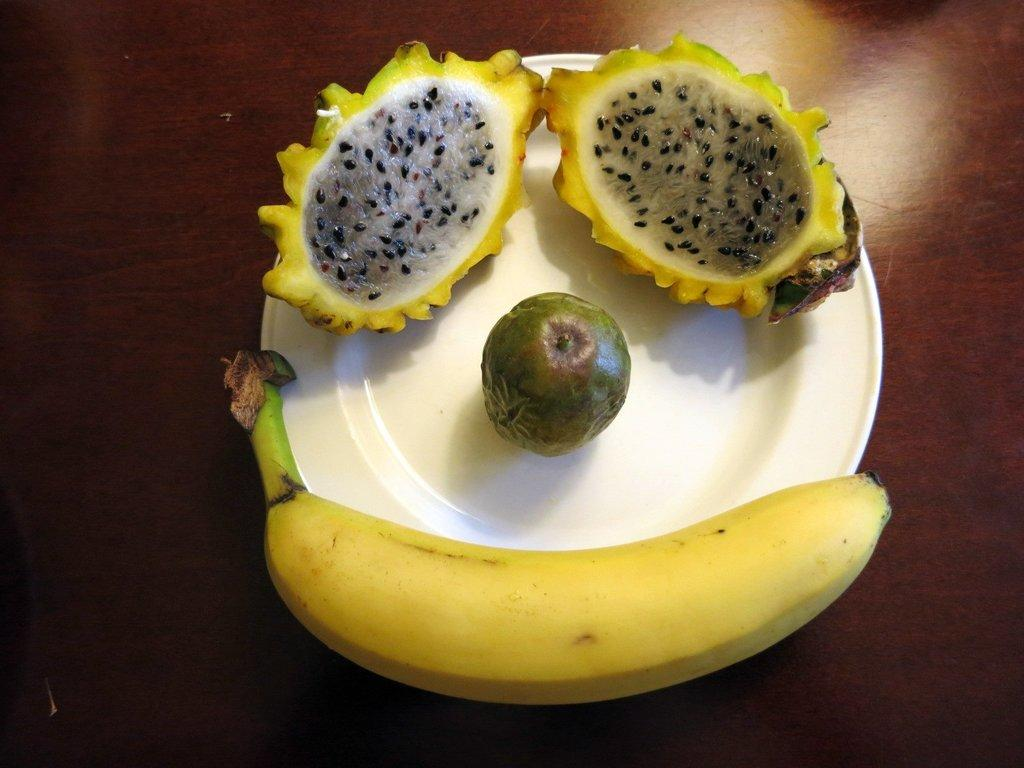What color is the plate that is visible in the image? The plate in the image is white. What is on the plate in the image? There are different types of fruits on the plate. How many trees can be seen in the image? There are no trees visible in the image; it only shows a plate with fruits. What type of humor is depicted in the image? There is no humor depicted in the image; it is a simple representation of a plate with fruits. 